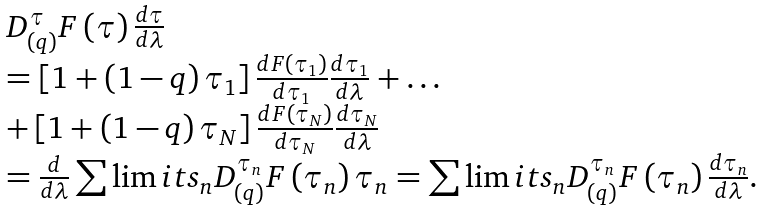<formula> <loc_0><loc_0><loc_500><loc_500>\begin{array} { l } D _ { \left ( q \right ) } ^ { \tau } F \left ( \tau \right ) \frac { d \tau } { d \lambda } \\ = \left [ { 1 + \left ( { 1 - q } \right ) \tau _ { 1 } } \right ] \frac { { d F \left ( { \tau _ { 1 } } \right ) } } { d \tau _ { 1 } } \frac { d \tau _ { 1 } } { d \lambda } + \dots \\ + \left [ { 1 + \left ( { 1 - q } \right ) \tau _ { N } } \right ] \frac { { d F \left ( { \tau _ { N } } \right ) } } { d \tau _ { N } } \frac { d \tau _ { N } } { d \lambda } \\ = \frac { d } { d \lambda } \sum \lim i t s _ { n } { D _ { \left ( q \right ) } ^ { \tau _ { n } } F \left ( { \tau _ { n } } \right ) \tau _ { n } } = \sum \lim i t s _ { n } { D _ { \left ( q \right ) } ^ { \tau _ { n } } F \left ( { \tau _ { n } } \right ) \frac { d \tau _ { n } } { d \lambda } } . \\ \end{array}</formula> 